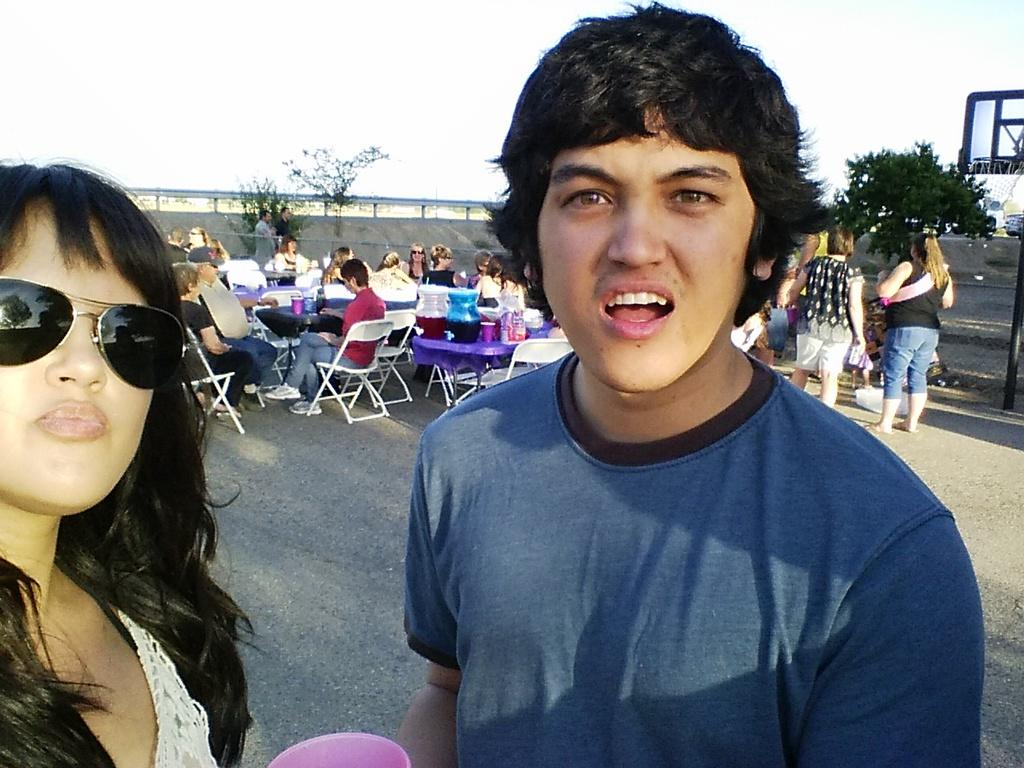How many persons can be seen in the image? There are persons in the image. What is the main object in the image? There is an object in the image, but the specific object is not mentioned in the facts. Can you describe the background of the image? In the background of the image, there are persons, chairs, plants, trees, and other objects. What is visible at the top of the image? The sky is visible at the top of the image. What type of discussion is taking place in the jail in the image? There is no jail or discussion present in the image. How long does the minute hand take to complete one full rotation in the image? There is no clock or time-related object present in the image to determine the position of the minute hand. 